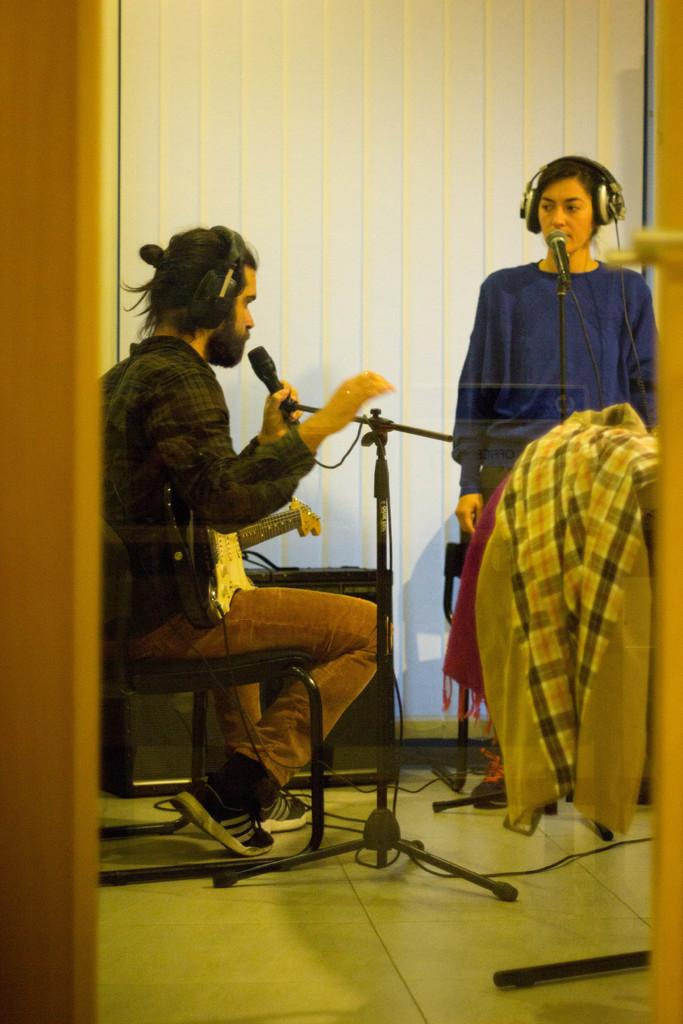What is the man in the image doing? The man is sitting on a chair and singing in the image. What is the man wearing in the image? The man is wearing a shirt, trousers, and shoes in the image. Who else is present in the image? There is a woman standing on the right side of the image. What is the woman wearing in the image? The woman is wearing a blue color top and a headset in the image. How many things are being operated by the man in the image? There is no information about any operation or thing being operated by the man in the image. 